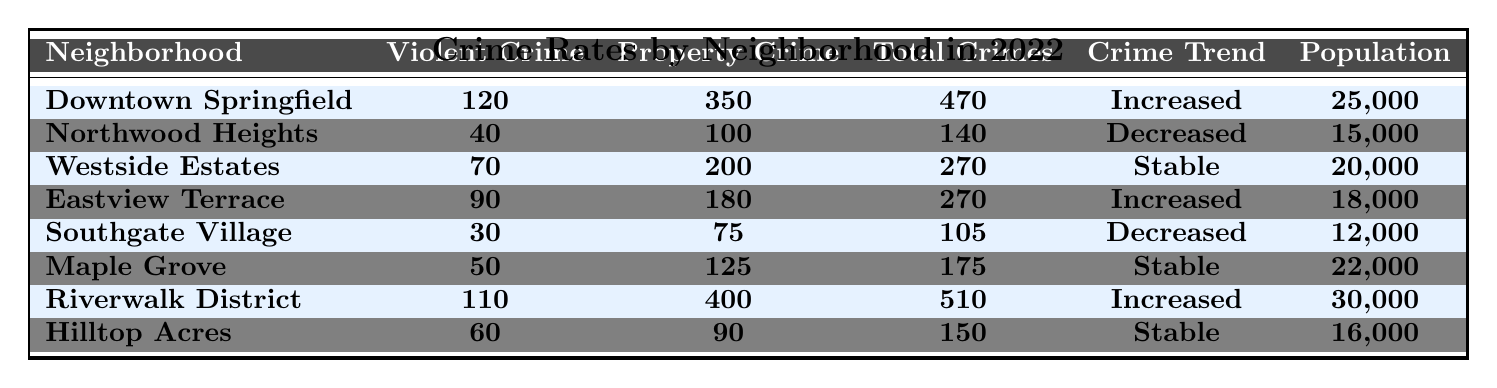What is the total number of crimes in Downtown Springfield? The table lists the total crimes in Downtown Springfield as 470.
Answer: 470 Which neighborhood has the highest property crime rate? According to the table, Riverwalk District has the highest property crime rate at 400.
Answer: Riverwalk District How many more total crimes were there in the Riverwalk District compared to Southgate Village? The total crimes for Riverwalk District is 510, and for Southgate Village, it is 105. The difference is 510 - 105 = 405.
Answer: 405 Is the crime trend in Maple Grove stable? The table indicates that Maple Grove has a crime trend labeled as "Stable."
Answer: Yes What is the average violent crime rate across all neighborhoods? Adding all violent crime rates: 120 + 40 + 70 + 90 + 30 + 50 + 110 + 60 = 570. There are 8 neighborhoods, so the average is 570 / 8 = 71.25.
Answer: 71.25 How many neighborhoods experienced an increase in crime trend? The table shows that Downtown Springfield, Eastview Terrace, and Riverwalk District have an increasing crime trend. This counts to three neighborhoods.
Answer: 3 Which neighborhood has the lowest total crimes? Southgate Village has the lowest total crimes at 105 as shown in the table.
Answer: Southgate Village What is the total population of neighborhoods with a decreasing crime trend? Northwood Heights has a population of 15,000 and Southgate Village has 12,000. The total population is 15,000 + 12,000 = 27,000.
Answer: 27,000 Are there more neighborhoods with an increased crime trend than with a decreased crime trend? There are three neighborhoods with an increased trend (Downtown Springfield, Eastview Terrace, Riverwalk District) and two with a decreased trend (Northwood Heights, Southgate Village), meaning there are more neighborhoods with an increased trend.
Answer: Yes What is the median property crime rate of the neighborhoods? The property crime rates are 350, 100, 200, 180, 75, 125, 400, and 90. When sorted (75, 90, 100, 125, 180, 200, 350, 400), the median of the eight values is (125 + 180)/2 = 152.5.
Answer: 152.5 